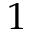<formula> <loc_0><loc_0><loc_500><loc_500>1</formula> 